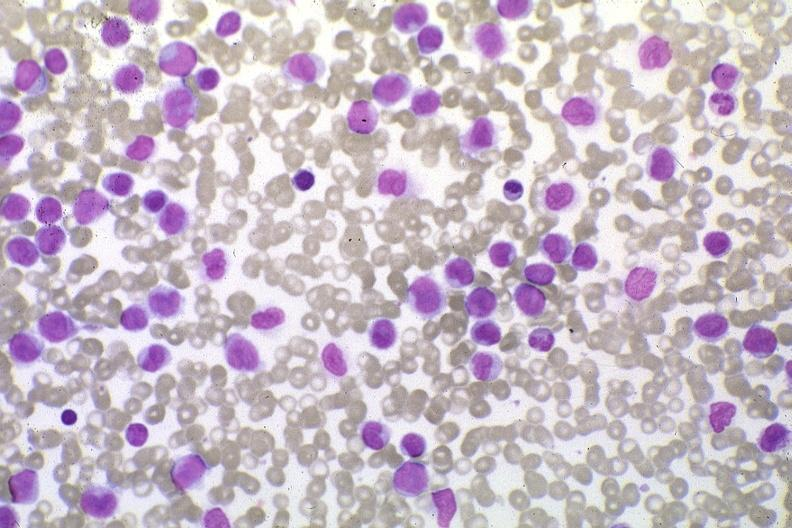does odontoid process subluxation with narrowing of foramen magnum show wrights stain pleomorphic leukemic cells in peripheral blood prior to therapy?
Answer the question using a single word or phrase. No 